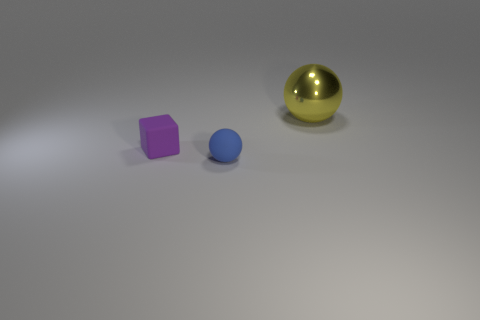Add 1 large objects. How many objects exist? 4 Subtract all cubes. How many objects are left? 2 Subtract all large yellow things. Subtract all big things. How many objects are left? 1 Add 3 small things. How many small things are left? 5 Add 1 cyan rubber cylinders. How many cyan rubber cylinders exist? 1 Subtract 0 cyan cubes. How many objects are left? 3 